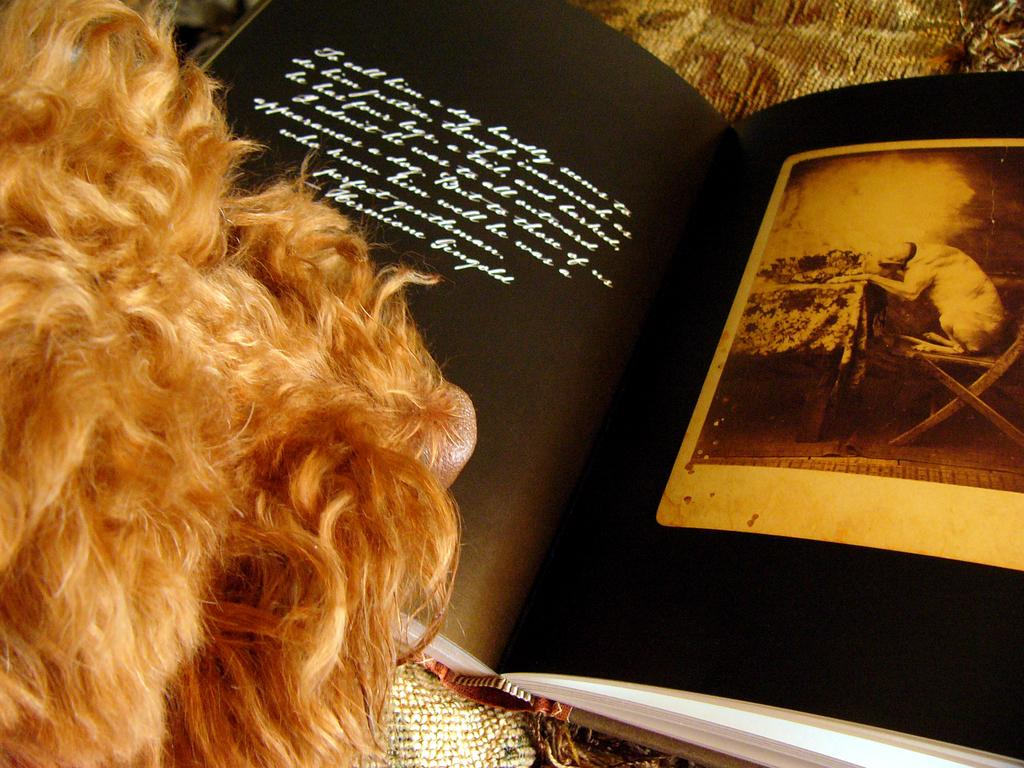What is depicted on the pages of the book in the image? There are pages of a book in the image. What can be seen on the cover of the book? The book has a picture on it. What is written on the book? There is writing on the book. What type of material is visible on the left side of the image? There is fur visible on the left side of the image. What type of garden is visible on the pages of the book? There is no garden depicted on the pages of the book; the image only shows the pages, cover, and writing of the book. 